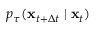<formula> <loc_0><loc_0><loc_500><loc_500>p _ { \tau } ( x _ { t + \Delta t } | x _ { t } )</formula> 